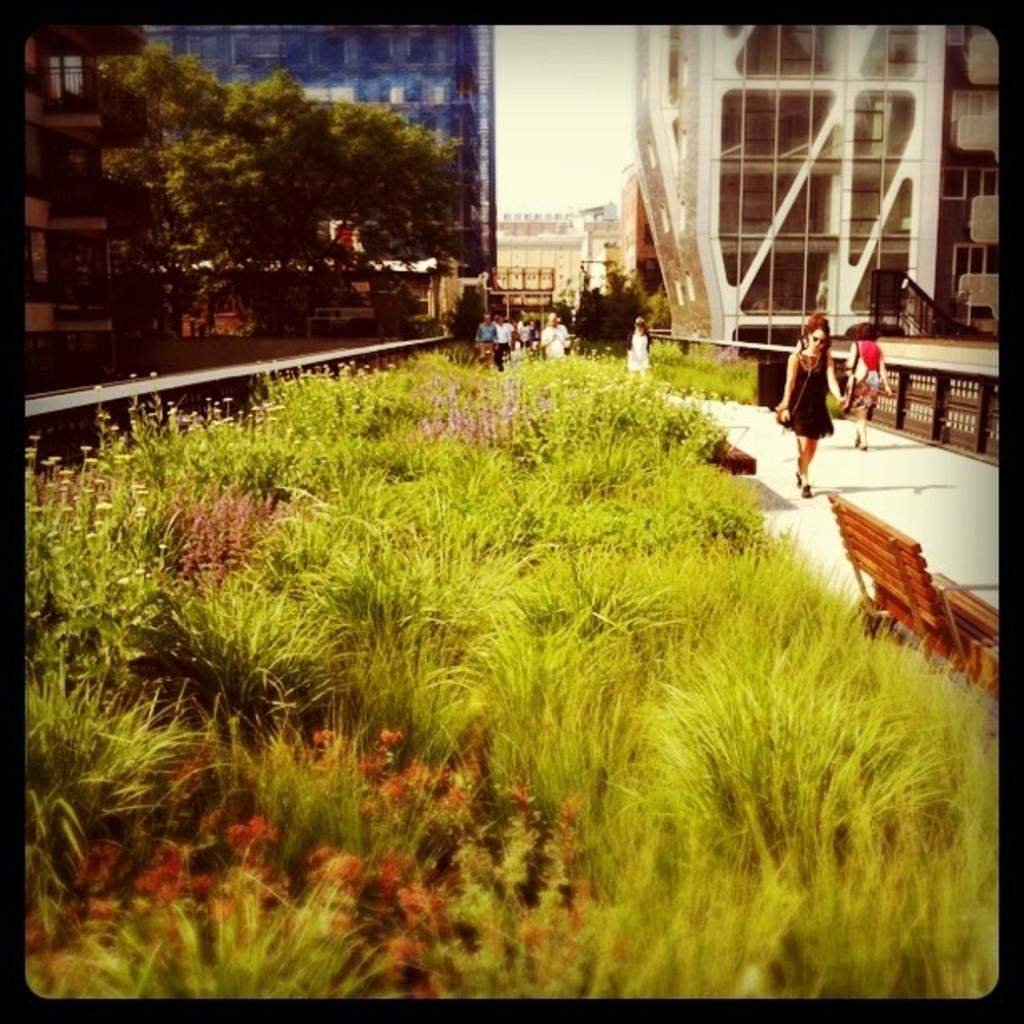What type of landscape is depicted in the center of the image? There is a grassland in the center of the image. Can you describe the people in the background of the image? There are people in the background of the image, but their specific actions or characteristics are not mentioned in the provided facts. What type of vegetation is on the left side of the image? There are trees on the left side of the image. What type of jam is being spread on the grassland by the mom in the image? There is no mom or jam present in the image; it features a grassland and people in the background. 